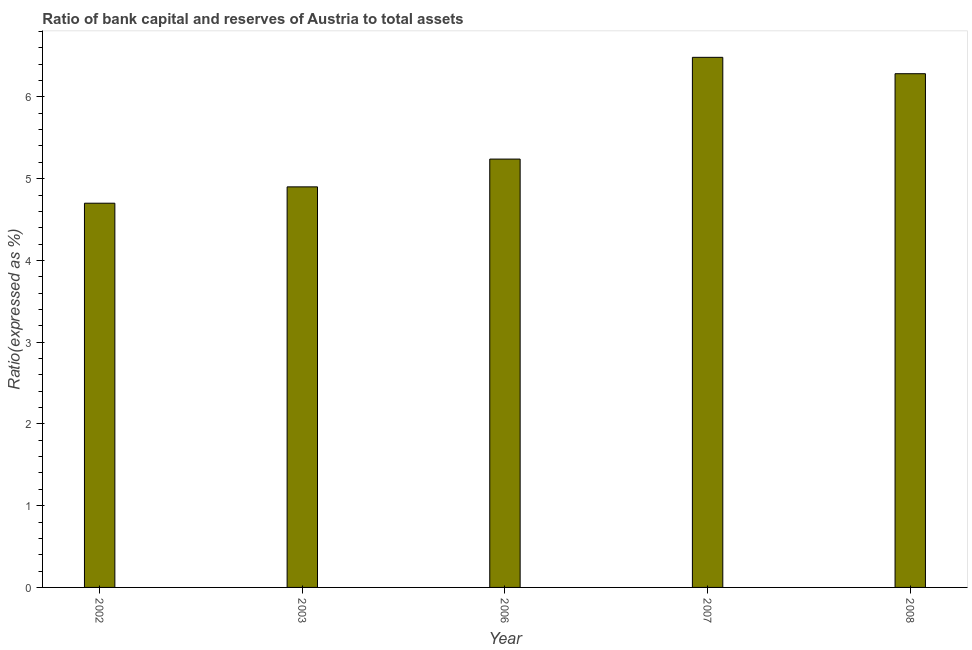Does the graph contain grids?
Provide a short and direct response. No. What is the title of the graph?
Provide a short and direct response. Ratio of bank capital and reserves of Austria to total assets. What is the label or title of the Y-axis?
Keep it short and to the point. Ratio(expressed as %). What is the bank capital to assets ratio in 2008?
Give a very brief answer. 6.28. Across all years, what is the maximum bank capital to assets ratio?
Your answer should be compact. 6.48. In which year was the bank capital to assets ratio maximum?
Your answer should be very brief. 2007. In which year was the bank capital to assets ratio minimum?
Your response must be concise. 2002. What is the sum of the bank capital to assets ratio?
Your response must be concise. 27.61. What is the difference between the bank capital to assets ratio in 2002 and 2006?
Make the answer very short. -0.54. What is the average bank capital to assets ratio per year?
Offer a very short reply. 5.52. What is the median bank capital to assets ratio?
Make the answer very short. 5.24. Do a majority of the years between 2008 and 2007 (inclusive) have bank capital to assets ratio greater than 0.2 %?
Offer a terse response. No. What is the ratio of the bank capital to assets ratio in 2006 to that in 2008?
Ensure brevity in your answer.  0.83. Is the sum of the bank capital to assets ratio in 2003 and 2008 greater than the maximum bank capital to assets ratio across all years?
Your response must be concise. Yes. What is the difference between the highest and the lowest bank capital to assets ratio?
Your answer should be very brief. 1.78. In how many years, is the bank capital to assets ratio greater than the average bank capital to assets ratio taken over all years?
Provide a short and direct response. 2. How many bars are there?
Make the answer very short. 5. What is the Ratio(expressed as %) of 2002?
Offer a terse response. 4.7. What is the Ratio(expressed as %) in 2003?
Give a very brief answer. 4.9. What is the Ratio(expressed as %) of 2006?
Make the answer very short. 5.24. What is the Ratio(expressed as %) in 2007?
Provide a succinct answer. 6.48. What is the Ratio(expressed as %) of 2008?
Your answer should be very brief. 6.28. What is the difference between the Ratio(expressed as %) in 2002 and 2006?
Offer a very short reply. -0.54. What is the difference between the Ratio(expressed as %) in 2002 and 2007?
Your response must be concise. -1.78. What is the difference between the Ratio(expressed as %) in 2002 and 2008?
Give a very brief answer. -1.58. What is the difference between the Ratio(expressed as %) in 2003 and 2006?
Keep it short and to the point. -0.34. What is the difference between the Ratio(expressed as %) in 2003 and 2007?
Your answer should be very brief. -1.58. What is the difference between the Ratio(expressed as %) in 2003 and 2008?
Offer a terse response. -1.38. What is the difference between the Ratio(expressed as %) in 2006 and 2007?
Provide a succinct answer. -1.24. What is the difference between the Ratio(expressed as %) in 2006 and 2008?
Your response must be concise. -1.04. What is the difference between the Ratio(expressed as %) in 2007 and 2008?
Provide a short and direct response. 0.2. What is the ratio of the Ratio(expressed as %) in 2002 to that in 2006?
Your answer should be very brief. 0.9. What is the ratio of the Ratio(expressed as %) in 2002 to that in 2007?
Offer a very short reply. 0.72. What is the ratio of the Ratio(expressed as %) in 2002 to that in 2008?
Your answer should be compact. 0.75. What is the ratio of the Ratio(expressed as %) in 2003 to that in 2006?
Provide a short and direct response. 0.94. What is the ratio of the Ratio(expressed as %) in 2003 to that in 2007?
Provide a succinct answer. 0.76. What is the ratio of the Ratio(expressed as %) in 2003 to that in 2008?
Make the answer very short. 0.78. What is the ratio of the Ratio(expressed as %) in 2006 to that in 2007?
Give a very brief answer. 0.81. What is the ratio of the Ratio(expressed as %) in 2006 to that in 2008?
Provide a short and direct response. 0.83. What is the ratio of the Ratio(expressed as %) in 2007 to that in 2008?
Offer a terse response. 1.03. 